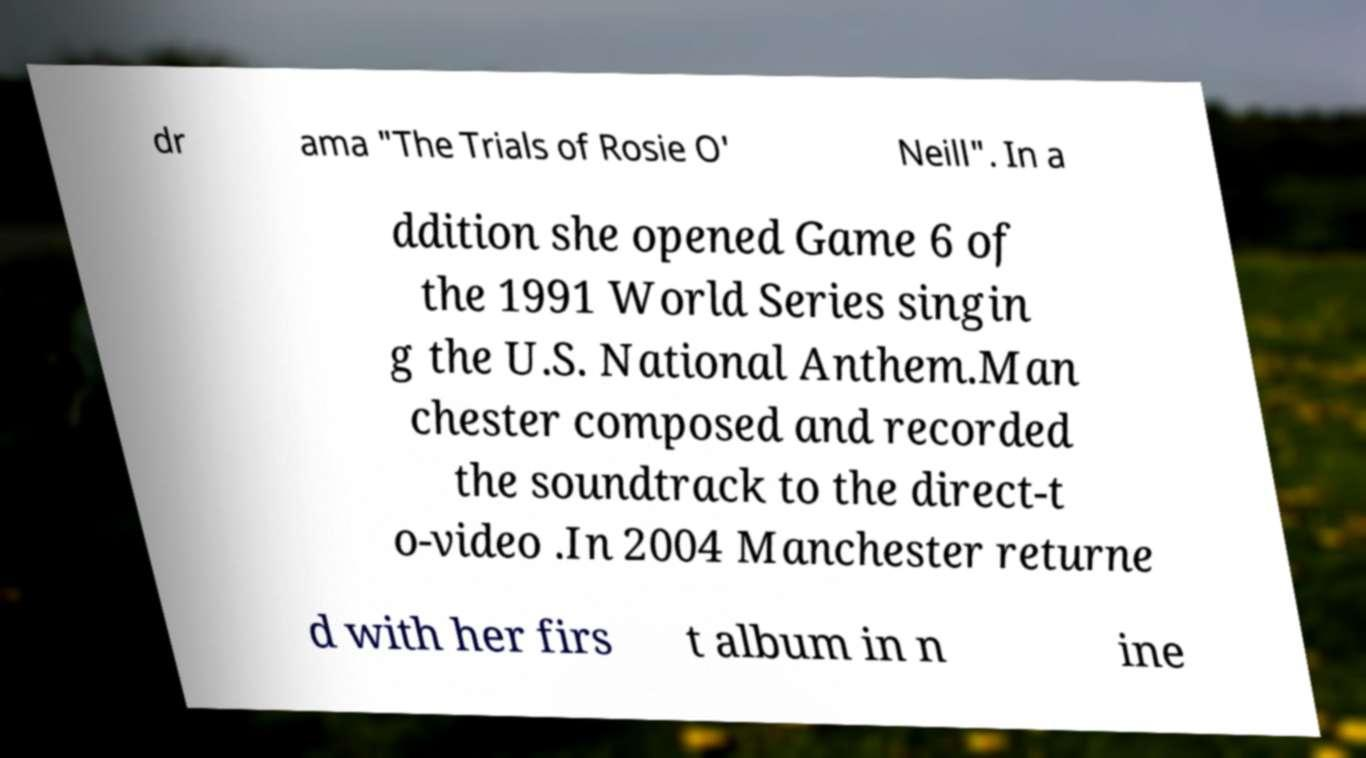Could you extract and type out the text from this image? dr ama "The Trials of Rosie O' Neill". In a ddition she opened Game 6 of the 1991 World Series singin g the U.S. National Anthem.Man chester composed and recorded the soundtrack to the direct-t o-video .In 2004 Manchester returne d with her firs t album in n ine 